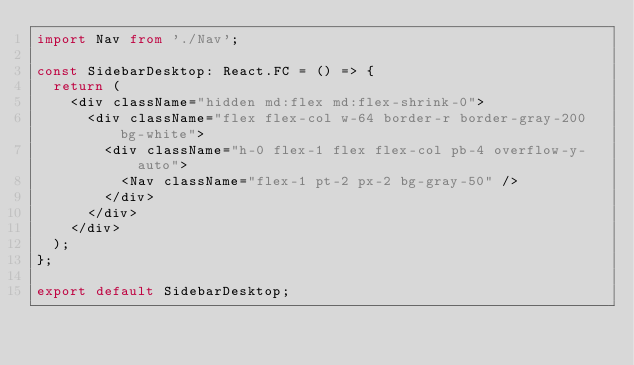<code> <loc_0><loc_0><loc_500><loc_500><_TypeScript_>import Nav from './Nav';

const SidebarDesktop: React.FC = () => {
  return (
    <div className="hidden md:flex md:flex-shrink-0">
      <div className="flex flex-col w-64 border-r border-gray-200 bg-white">
        <div className="h-0 flex-1 flex flex-col pb-4 overflow-y-auto">
          <Nav className="flex-1 pt-2 px-2 bg-gray-50" />
        </div>
      </div>
    </div>
  );
};

export default SidebarDesktop;
</code> 